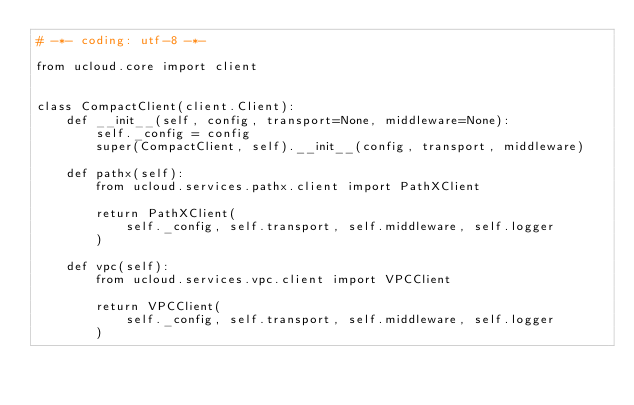Convert code to text. <code><loc_0><loc_0><loc_500><loc_500><_Python_># -*- coding: utf-8 -*-

from ucloud.core import client


class CompactClient(client.Client):
    def __init__(self, config, transport=None, middleware=None):
        self._config = config
        super(CompactClient, self).__init__(config, transport, middleware)

    def pathx(self):
        from ucloud.services.pathx.client import PathXClient

        return PathXClient(
            self._config, self.transport, self.middleware, self.logger
        )

    def vpc(self):
        from ucloud.services.vpc.client import VPCClient

        return VPCClient(
            self._config, self.transport, self.middleware, self.logger
        )
</code> 